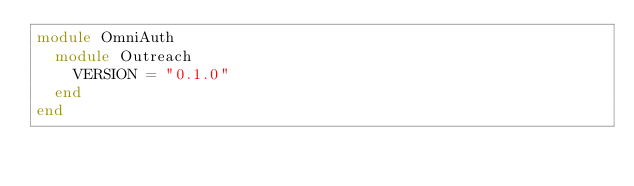<code> <loc_0><loc_0><loc_500><loc_500><_Ruby_>module OmniAuth
  module Outreach
    VERSION = "0.1.0"
  end
end
</code> 